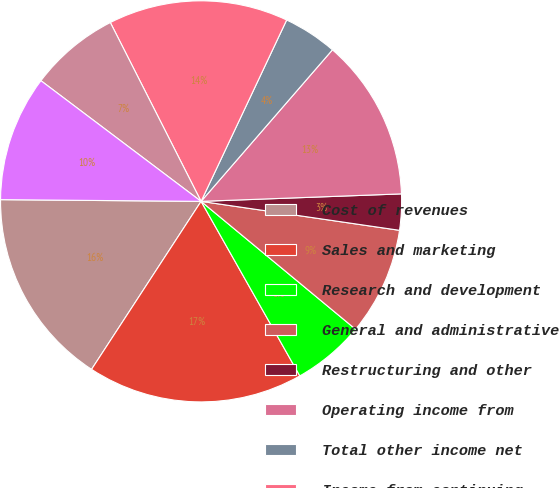Convert chart. <chart><loc_0><loc_0><loc_500><loc_500><pie_chart><fcel>Cost of revenues<fcel>Sales and marketing<fcel>Research and development<fcel>General and administrative<fcel>Restructuring and other<fcel>Operating income from<fcel>Total other income net<fcel>Income from continuing<fcel>Income tax expense<fcel>Net income from continuing<nl><fcel>15.94%<fcel>17.39%<fcel>5.8%<fcel>8.7%<fcel>2.9%<fcel>13.04%<fcel>4.35%<fcel>14.49%<fcel>7.25%<fcel>10.14%<nl></chart> 